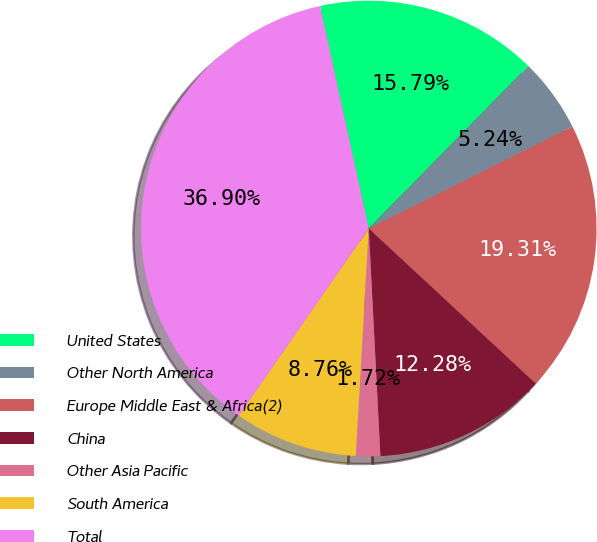<chart> <loc_0><loc_0><loc_500><loc_500><pie_chart><fcel>United States<fcel>Other North America<fcel>Europe Middle East & Africa(2)<fcel>China<fcel>Other Asia Pacific<fcel>South America<fcel>Total<nl><fcel>15.79%<fcel>5.24%<fcel>19.31%<fcel>12.28%<fcel>1.72%<fcel>8.76%<fcel>36.9%<nl></chart> 